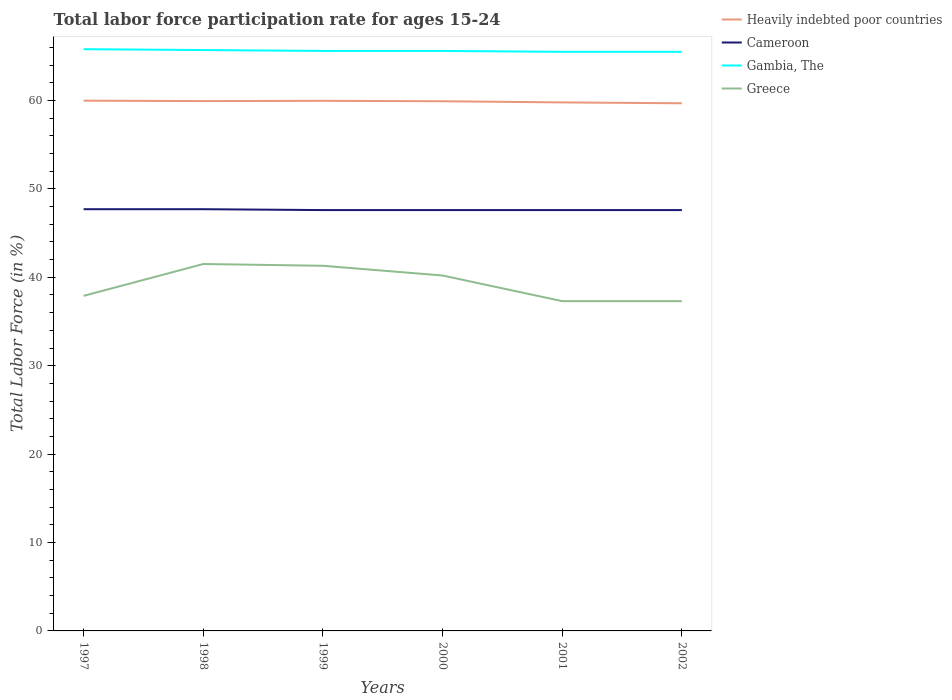Across all years, what is the maximum labor force participation rate in Cameroon?
Offer a terse response. 47.6. In which year was the labor force participation rate in Heavily indebted poor countries maximum?
Offer a very short reply. 2002. What is the total labor force participation rate in Cameroon in the graph?
Provide a succinct answer. 0. What is the difference between the highest and the second highest labor force participation rate in Cameroon?
Offer a very short reply. 0.1. What is the difference between the highest and the lowest labor force participation rate in Heavily indebted poor countries?
Your answer should be very brief. 4. Is the labor force participation rate in Heavily indebted poor countries strictly greater than the labor force participation rate in Greece over the years?
Ensure brevity in your answer.  No. How many lines are there?
Keep it short and to the point. 4. How many years are there in the graph?
Your answer should be compact. 6. What is the difference between two consecutive major ticks on the Y-axis?
Keep it short and to the point. 10. Does the graph contain any zero values?
Provide a short and direct response. No. Where does the legend appear in the graph?
Make the answer very short. Top right. How many legend labels are there?
Keep it short and to the point. 4. How are the legend labels stacked?
Offer a terse response. Vertical. What is the title of the graph?
Your response must be concise. Total labor force participation rate for ages 15-24. Does "Micronesia" appear as one of the legend labels in the graph?
Provide a short and direct response. No. What is the label or title of the X-axis?
Offer a terse response. Years. What is the Total Labor Force (in %) in Heavily indebted poor countries in 1997?
Your answer should be compact. 59.98. What is the Total Labor Force (in %) in Cameroon in 1997?
Your answer should be very brief. 47.7. What is the Total Labor Force (in %) of Gambia, The in 1997?
Give a very brief answer. 65.8. What is the Total Labor Force (in %) in Greece in 1997?
Your response must be concise. 37.9. What is the Total Labor Force (in %) of Heavily indebted poor countries in 1998?
Provide a succinct answer. 59.93. What is the Total Labor Force (in %) in Cameroon in 1998?
Offer a terse response. 47.7. What is the Total Labor Force (in %) in Gambia, The in 1998?
Ensure brevity in your answer.  65.7. What is the Total Labor Force (in %) in Greece in 1998?
Offer a very short reply. 41.5. What is the Total Labor Force (in %) in Heavily indebted poor countries in 1999?
Make the answer very short. 59.96. What is the Total Labor Force (in %) of Cameroon in 1999?
Make the answer very short. 47.6. What is the Total Labor Force (in %) of Gambia, The in 1999?
Provide a succinct answer. 65.6. What is the Total Labor Force (in %) of Greece in 1999?
Make the answer very short. 41.3. What is the Total Labor Force (in %) in Heavily indebted poor countries in 2000?
Provide a short and direct response. 59.91. What is the Total Labor Force (in %) of Cameroon in 2000?
Offer a very short reply. 47.6. What is the Total Labor Force (in %) in Gambia, The in 2000?
Your answer should be very brief. 65.6. What is the Total Labor Force (in %) in Greece in 2000?
Offer a very short reply. 40.2. What is the Total Labor Force (in %) of Heavily indebted poor countries in 2001?
Your answer should be very brief. 59.78. What is the Total Labor Force (in %) of Cameroon in 2001?
Your answer should be very brief. 47.6. What is the Total Labor Force (in %) in Gambia, The in 2001?
Your answer should be compact. 65.5. What is the Total Labor Force (in %) in Greece in 2001?
Give a very brief answer. 37.3. What is the Total Labor Force (in %) of Heavily indebted poor countries in 2002?
Make the answer very short. 59.68. What is the Total Labor Force (in %) of Cameroon in 2002?
Provide a succinct answer. 47.6. What is the Total Labor Force (in %) in Gambia, The in 2002?
Provide a short and direct response. 65.5. What is the Total Labor Force (in %) of Greece in 2002?
Make the answer very short. 37.3. Across all years, what is the maximum Total Labor Force (in %) in Heavily indebted poor countries?
Provide a succinct answer. 59.98. Across all years, what is the maximum Total Labor Force (in %) of Cameroon?
Offer a very short reply. 47.7. Across all years, what is the maximum Total Labor Force (in %) of Gambia, The?
Provide a short and direct response. 65.8. Across all years, what is the maximum Total Labor Force (in %) of Greece?
Offer a terse response. 41.5. Across all years, what is the minimum Total Labor Force (in %) of Heavily indebted poor countries?
Offer a very short reply. 59.68. Across all years, what is the minimum Total Labor Force (in %) in Cameroon?
Your answer should be compact. 47.6. Across all years, what is the minimum Total Labor Force (in %) in Gambia, The?
Give a very brief answer. 65.5. Across all years, what is the minimum Total Labor Force (in %) in Greece?
Offer a terse response. 37.3. What is the total Total Labor Force (in %) in Heavily indebted poor countries in the graph?
Your response must be concise. 359.23. What is the total Total Labor Force (in %) of Cameroon in the graph?
Give a very brief answer. 285.8. What is the total Total Labor Force (in %) of Gambia, The in the graph?
Offer a very short reply. 393.7. What is the total Total Labor Force (in %) of Greece in the graph?
Keep it short and to the point. 235.5. What is the difference between the Total Labor Force (in %) of Heavily indebted poor countries in 1997 and that in 1998?
Your answer should be compact. 0.05. What is the difference between the Total Labor Force (in %) of Cameroon in 1997 and that in 1998?
Offer a terse response. 0. What is the difference between the Total Labor Force (in %) in Heavily indebted poor countries in 1997 and that in 1999?
Your answer should be compact. 0.02. What is the difference between the Total Labor Force (in %) of Cameroon in 1997 and that in 1999?
Make the answer very short. 0.1. What is the difference between the Total Labor Force (in %) of Gambia, The in 1997 and that in 1999?
Your answer should be compact. 0.2. What is the difference between the Total Labor Force (in %) of Heavily indebted poor countries in 1997 and that in 2000?
Offer a very short reply. 0.07. What is the difference between the Total Labor Force (in %) in Cameroon in 1997 and that in 2000?
Your response must be concise. 0.1. What is the difference between the Total Labor Force (in %) in Gambia, The in 1997 and that in 2000?
Provide a short and direct response. 0.2. What is the difference between the Total Labor Force (in %) of Heavily indebted poor countries in 1997 and that in 2001?
Give a very brief answer. 0.2. What is the difference between the Total Labor Force (in %) of Cameroon in 1997 and that in 2001?
Offer a very short reply. 0.1. What is the difference between the Total Labor Force (in %) of Gambia, The in 1997 and that in 2001?
Offer a very short reply. 0.3. What is the difference between the Total Labor Force (in %) in Heavily indebted poor countries in 1997 and that in 2002?
Keep it short and to the point. 0.3. What is the difference between the Total Labor Force (in %) in Cameroon in 1997 and that in 2002?
Ensure brevity in your answer.  0.1. What is the difference between the Total Labor Force (in %) in Heavily indebted poor countries in 1998 and that in 1999?
Keep it short and to the point. -0.03. What is the difference between the Total Labor Force (in %) in Cameroon in 1998 and that in 1999?
Your response must be concise. 0.1. What is the difference between the Total Labor Force (in %) of Heavily indebted poor countries in 1998 and that in 2000?
Your response must be concise. 0.02. What is the difference between the Total Labor Force (in %) in Greece in 1998 and that in 2000?
Give a very brief answer. 1.3. What is the difference between the Total Labor Force (in %) in Heavily indebted poor countries in 1998 and that in 2001?
Your answer should be very brief. 0.15. What is the difference between the Total Labor Force (in %) of Cameroon in 1998 and that in 2001?
Offer a very short reply. 0.1. What is the difference between the Total Labor Force (in %) in Gambia, The in 1998 and that in 2001?
Your answer should be very brief. 0.2. What is the difference between the Total Labor Force (in %) of Greece in 1998 and that in 2001?
Offer a very short reply. 4.2. What is the difference between the Total Labor Force (in %) of Heavily indebted poor countries in 1998 and that in 2002?
Your answer should be compact. 0.25. What is the difference between the Total Labor Force (in %) of Gambia, The in 1998 and that in 2002?
Provide a short and direct response. 0.2. What is the difference between the Total Labor Force (in %) of Heavily indebted poor countries in 1999 and that in 2000?
Provide a short and direct response. 0.05. What is the difference between the Total Labor Force (in %) of Heavily indebted poor countries in 1999 and that in 2001?
Your response must be concise. 0.18. What is the difference between the Total Labor Force (in %) in Gambia, The in 1999 and that in 2001?
Offer a terse response. 0.1. What is the difference between the Total Labor Force (in %) in Greece in 1999 and that in 2001?
Your answer should be very brief. 4. What is the difference between the Total Labor Force (in %) in Heavily indebted poor countries in 1999 and that in 2002?
Give a very brief answer. 0.28. What is the difference between the Total Labor Force (in %) in Cameroon in 1999 and that in 2002?
Keep it short and to the point. 0. What is the difference between the Total Labor Force (in %) of Greece in 1999 and that in 2002?
Offer a very short reply. 4. What is the difference between the Total Labor Force (in %) in Heavily indebted poor countries in 2000 and that in 2001?
Your response must be concise. 0.13. What is the difference between the Total Labor Force (in %) of Cameroon in 2000 and that in 2001?
Your response must be concise. 0. What is the difference between the Total Labor Force (in %) in Gambia, The in 2000 and that in 2001?
Keep it short and to the point. 0.1. What is the difference between the Total Labor Force (in %) in Greece in 2000 and that in 2001?
Ensure brevity in your answer.  2.9. What is the difference between the Total Labor Force (in %) in Heavily indebted poor countries in 2000 and that in 2002?
Offer a terse response. 0.23. What is the difference between the Total Labor Force (in %) of Greece in 2000 and that in 2002?
Your answer should be compact. 2.9. What is the difference between the Total Labor Force (in %) of Heavily indebted poor countries in 2001 and that in 2002?
Make the answer very short. 0.1. What is the difference between the Total Labor Force (in %) of Gambia, The in 2001 and that in 2002?
Ensure brevity in your answer.  0. What is the difference between the Total Labor Force (in %) of Greece in 2001 and that in 2002?
Your answer should be very brief. 0. What is the difference between the Total Labor Force (in %) in Heavily indebted poor countries in 1997 and the Total Labor Force (in %) in Cameroon in 1998?
Your answer should be compact. 12.28. What is the difference between the Total Labor Force (in %) in Heavily indebted poor countries in 1997 and the Total Labor Force (in %) in Gambia, The in 1998?
Keep it short and to the point. -5.72. What is the difference between the Total Labor Force (in %) in Heavily indebted poor countries in 1997 and the Total Labor Force (in %) in Greece in 1998?
Your answer should be compact. 18.48. What is the difference between the Total Labor Force (in %) in Cameroon in 1997 and the Total Labor Force (in %) in Gambia, The in 1998?
Keep it short and to the point. -18. What is the difference between the Total Labor Force (in %) of Cameroon in 1997 and the Total Labor Force (in %) of Greece in 1998?
Your response must be concise. 6.2. What is the difference between the Total Labor Force (in %) in Gambia, The in 1997 and the Total Labor Force (in %) in Greece in 1998?
Offer a terse response. 24.3. What is the difference between the Total Labor Force (in %) in Heavily indebted poor countries in 1997 and the Total Labor Force (in %) in Cameroon in 1999?
Ensure brevity in your answer.  12.38. What is the difference between the Total Labor Force (in %) of Heavily indebted poor countries in 1997 and the Total Labor Force (in %) of Gambia, The in 1999?
Your response must be concise. -5.62. What is the difference between the Total Labor Force (in %) of Heavily indebted poor countries in 1997 and the Total Labor Force (in %) of Greece in 1999?
Your response must be concise. 18.68. What is the difference between the Total Labor Force (in %) in Cameroon in 1997 and the Total Labor Force (in %) in Gambia, The in 1999?
Your answer should be compact. -17.9. What is the difference between the Total Labor Force (in %) in Cameroon in 1997 and the Total Labor Force (in %) in Greece in 1999?
Your answer should be compact. 6.4. What is the difference between the Total Labor Force (in %) in Gambia, The in 1997 and the Total Labor Force (in %) in Greece in 1999?
Your answer should be compact. 24.5. What is the difference between the Total Labor Force (in %) in Heavily indebted poor countries in 1997 and the Total Labor Force (in %) in Cameroon in 2000?
Make the answer very short. 12.38. What is the difference between the Total Labor Force (in %) of Heavily indebted poor countries in 1997 and the Total Labor Force (in %) of Gambia, The in 2000?
Keep it short and to the point. -5.62. What is the difference between the Total Labor Force (in %) in Heavily indebted poor countries in 1997 and the Total Labor Force (in %) in Greece in 2000?
Your response must be concise. 19.78. What is the difference between the Total Labor Force (in %) of Cameroon in 1997 and the Total Labor Force (in %) of Gambia, The in 2000?
Your response must be concise. -17.9. What is the difference between the Total Labor Force (in %) in Cameroon in 1997 and the Total Labor Force (in %) in Greece in 2000?
Your response must be concise. 7.5. What is the difference between the Total Labor Force (in %) in Gambia, The in 1997 and the Total Labor Force (in %) in Greece in 2000?
Your response must be concise. 25.6. What is the difference between the Total Labor Force (in %) of Heavily indebted poor countries in 1997 and the Total Labor Force (in %) of Cameroon in 2001?
Your response must be concise. 12.38. What is the difference between the Total Labor Force (in %) of Heavily indebted poor countries in 1997 and the Total Labor Force (in %) of Gambia, The in 2001?
Offer a very short reply. -5.52. What is the difference between the Total Labor Force (in %) in Heavily indebted poor countries in 1997 and the Total Labor Force (in %) in Greece in 2001?
Offer a very short reply. 22.68. What is the difference between the Total Labor Force (in %) in Cameroon in 1997 and the Total Labor Force (in %) in Gambia, The in 2001?
Offer a very short reply. -17.8. What is the difference between the Total Labor Force (in %) of Cameroon in 1997 and the Total Labor Force (in %) of Greece in 2001?
Provide a short and direct response. 10.4. What is the difference between the Total Labor Force (in %) in Gambia, The in 1997 and the Total Labor Force (in %) in Greece in 2001?
Your response must be concise. 28.5. What is the difference between the Total Labor Force (in %) of Heavily indebted poor countries in 1997 and the Total Labor Force (in %) of Cameroon in 2002?
Offer a terse response. 12.38. What is the difference between the Total Labor Force (in %) in Heavily indebted poor countries in 1997 and the Total Labor Force (in %) in Gambia, The in 2002?
Your answer should be very brief. -5.52. What is the difference between the Total Labor Force (in %) in Heavily indebted poor countries in 1997 and the Total Labor Force (in %) in Greece in 2002?
Make the answer very short. 22.68. What is the difference between the Total Labor Force (in %) of Cameroon in 1997 and the Total Labor Force (in %) of Gambia, The in 2002?
Offer a very short reply. -17.8. What is the difference between the Total Labor Force (in %) of Cameroon in 1997 and the Total Labor Force (in %) of Greece in 2002?
Your response must be concise. 10.4. What is the difference between the Total Labor Force (in %) of Gambia, The in 1997 and the Total Labor Force (in %) of Greece in 2002?
Your answer should be very brief. 28.5. What is the difference between the Total Labor Force (in %) in Heavily indebted poor countries in 1998 and the Total Labor Force (in %) in Cameroon in 1999?
Make the answer very short. 12.33. What is the difference between the Total Labor Force (in %) of Heavily indebted poor countries in 1998 and the Total Labor Force (in %) of Gambia, The in 1999?
Your response must be concise. -5.67. What is the difference between the Total Labor Force (in %) of Heavily indebted poor countries in 1998 and the Total Labor Force (in %) of Greece in 1999?
Offer a very short reply. 18.63. What is the difference between the Total Labor Force (in %) in Cameroon in 1998 and the Total Labor Force (in %) in Gambia, The in 1999?
Make the answer very short. -17.9. What is the difference between the Total Labor Force (in %) in Gambia, The in 1998 and the Total Labor Force (in %) in Greece in 1999?
Offer a very short reply. 24.4. What is the difference between the Total Labor Force (in %) in Heavily indebted poor countries in 1998 and the Total Labor Force (in %) in Cameroon in 2000?
Make the answer very short. 12.33. What is the difference between the Total Labor Force (in %) in Heavily indebted poor countries in 1998 and the Total Labor Force (in %) in Gambia, The in 2000?
Provide a short and direct response. -5.67. What is the difference between the Total Labor Force (in %) in Heavily indebted poor countries in 1998 and the Total Labor Force (in %) in Greece in 2000?
Your answer should be very brief. 19.73. What is the difference between the Total Labor Force (in %) of Cameroon in 1998 and the Total Labor Force (in %) of Gambia, The in 2000?
Provide a succinct answer. -17.9. What is the difference between the Total Labor Force (in %) of Heavily indebted poor countries in 1998 and the Total Labor Force (in %) of Cameroon in 2001?
Your answer should be very brief. 12.33. What is the difference between the Total Labor Force (in %) of Heavily indebted poor countries in 1998 and the Total Labor Force (in %) of Gambia, The in 2001?
Offer a terse response. -5.57. What is the difference between the Total Labor Force (in %) of Heavily indebted poor countries in 1998 and the Total Labor Force (in %) of Greece in 2001?
Offer a very short reply. 22.63. What is the difference between the Total Labor Force (in %) in Cameroon in 1998 and the Total Labor Force (in %) in Gambia, The in 2001?
Ensure brevity in your answer.  -17.8. What is the difference between the Total Labor Force (in %) of Cameroon in 1998 and the Total Labor Force (in %) of Greece in 2001?
Ensure brevity in your answer.  10.4. What is the difference between the Total Labor Force (in %) in Gambia, The in 1998 and the Total Labor Force (in %) in Greece in 2001?
Offer a very short reply. 28.4. What is the difference between the Total Labor Force (in %) in Heavily indebted poor countries in 1998 and the Total Labor Force (in %) in Cameroon in 2002?
Keep it short and to the point. 12.33. What is the difference between the Total Labor Force (in %) in Heavily indebted poor countries in 1998 and the Total Labor Force (in %) in Gambia, The in 2002?
Offer a terse response. -5.57. What is the difference between the Total Labor Force (in %) in Heavily indebted poor countries in 1998 and the Total Labor Force (in %) in Greece in 2002?
Your response must be concise. 22.63. What is the difference between the Total Labor Force (in %) of Cameroon in 1998 and the Total Labor Force (in %) of Gambia, The in 2002?
Your answer should be very brief. -17.8. What is the difference between the Total Labor Force (in %) of Cameroon in 1998 and the Total Labor Force (in %) of Greece in 2002?
Ensure brevity in your answer.  10.4. What is the difference between the Total Labor Force (in %) in Gambia, The in 1998 and the Total Labor Force (in %) in Greece in 2002?
Your response must be concise. 28.4. What is the difference between the Total Labor Force (in %) of Heavily indebted poor countries in 1999 and the Total Labor Force (in %) of Cameroon in 2000?
Keep it short and to the point. 12.36. What is the difference between the Total Labor Force (in %) in Heavily indebted poor countries in 1999 and the Total Labor Force (in %) in Gambia, The in 2000?
Offer a very short reply. -5.64. What is the difference between the Total Labor Force (in %) of Heavily indebted poor countries in 1999 and the Total Labor Force (in %) of Greece in 2000?
Your answer should be compact. 19.76. What is the difference between the Total Labor Force (in %) of Cameroon in 1999 and the Total Labor Force (in %) of Gambia, The in 2000?
Your answer should be compact. -18. What is the difference between the Total Labor Force (in %) in Gambia, The in 1999 and the Total Labor Force (in %) in Greece in 2000?
Ensure brevity in your answer.  25.4. What is the difference between the Total Labor Force (in %) in Heavily indebted poor countries in 1999 and the Total Labor Force (in %) in Cameroon in 2001?
Your response must be concise. 12.36. What is the difference between the Total Labor Force (in %) of Heavily indebted poor countries in 1999 and the Total Labor Force (in %) of Gambia, The in 2001?
Keep it short and to the point. -5.54. What is the difference between the Total Labor Force (in %) in Heavily indebted poor countries in 1999 and the Total Labor Force (in %) in Greece in 2001?
Provide a succinct answer. 22.66. What is the difference between the Total Labor Force (in %) in Cameroon in 1999 and the Total Labor Force (in %) in Gambia, The in 2001?
Keep it short and to the point. -17.9. What is the difference between the Total Labor Force (in %) of Cameroon in 1999 and the Total Labor Force (in %) of Greece in 2001?
Give a very brief answer. 10.3. What is the difference between the Total Labor Force (in %) of Gambia, The in 1999 and the Total Labor Force (in %) of Greece in 2001?
Offer a terse response. 28.3. What is the difference between the Total Labor Force (in %) in Heavily indebted poor countries in 1999 and the Total Labor Force (in %) in Cameroon in 2002?
Provide a short and direct response. 12.36. What is the difference between the Total Labor Force (in %) in Heavily indebted poor countries in 1999 and the Total Labor Force (in %) in Gambia, The in 2002?
Make the answer very short. -5.54. What is the difference between the Total Labor Force (in %) of Heavily indebted poor countries in 1999 and the Total Labor Force (in %) of Greece in 2002?
Your answer should be very brief. 22.66. What is the difference between the Total Labor Force (in %) of Cameroon in 1999 and the Total Labor Force (in %) of Gambia, The in 2002?
Provide a short and direct response. -17.9. What is the difference between the Total Labor Force (in %) in Cameroon in 1999 and the Total Labor Force (in %) in Greece in 2002?
Provide a succinct answer. 10.3. What is the difference between the Total Labor Force (in %) of Gambia, The in 1999 and the Total Labor Force (in %) of Greece in 2002?
Your answer should be very brief. 28.3. What is the difference between the Total Labor Force (in %) in Heavily indebted poor countries in 2000 and the Total Labor Force (in %) in Cameroon in 2001?
Your answer should be compact. 12.31. What is the difference between the Total Labor Force (in %) in Heavily indebted poor countries in 2000 and the Total Labor Force (in %) in Gambia, The in 2001?
Your answer should be compact. -5.59. What is the difference between the Total Labor Force (in %) in Heavily indebted poor countries in 2000 and the Total Labor Force (in %) in Greece in 2001?
Provide a short and direct response. 22.61. What is the difference between the Total Labor Force (in %) in Cameroon in 2000 and the Total Labor Force (in %) in Gambia, The in 2001?
Keep it short and to the point. -17.9. What is the difference between the Total Labor Force (in %) of Gambia, The in 2000 and the Total Labor Force (in %) of Greece in 2001?
Give a very brief answer. 28.3. What is the difference between the Total Labor Force (in %) in Heavily indebted poor countries in 2000 and the Total Labor Force (in %) in Cameroon in 2002?
Make the answer very short. 12.31. What is the difference between the Total Labor Force (in %) of Heavily indebted poor countries in 2000 and the Total Labor Force (in %) of Gambia, The in 2002?
Provide a succinct answer. -5.59. What is the difference between the Total Labor Force (in %) of Heavily indebted poor countries in 2000 and the Total Labor Force (in %) of Greece in 2002?
Your answer should be compact. 22.61. What is the difference between the Total Labor Force (in %) of Cameroon in 2000 and the Total Labor Force (in %) of Gambia, The in 2002?
Your response must be concise. -17.9. What is the difference between the Total Labor Force (in %) in Cameroon in 2000 and the Total Labor Force (in %) in Greece in 2002?
Keep it short and to the point. 10.3. What is the difference between the Total Labor Force (in %) of Gambia, The in 2000 and the Total Labor Force (in %) of Greece in 2002?
Your answer should be very brief. 28.3. What is the difference between the Total Labor Force (in %) of Heavily indebted poor countries in 2001 and the Total Labor Force (in %) of Cameroon in 2002?
Your response must be concise. 12.18. What is the difference between the Total Labor Force (in %) in Heavily indebted poor countries in 2001 and the Total Labor Force (in %) in Gambia, The in 2002?
Provide a succinct answer. -5.72. What is the difference between the Total Labor Force (in %) in Heavily indebted poor countries in 2001 and the Total Labor Force (in %) in Greece in 2002?
Offer a terse response. 22.48. What is the difference between the Total Labor Force (in %) of Cameroon in 2001 and the Total Labor Force (in %) of Gambia, The in 2002?
Give a very brief answer. -17.9. What is the difference between the Total Labor Force (in %) of Cameroon in 2001 and the Total Labor Force (in %) of Greece in 2002?
Keep it short and to the point. 10.3. What is the difference between the Total Labor Force (in %) in Gambia, The in 2001 and the Total Labor Force (in %) in Greece in 2002?
Offer a terse response. 28.2. What is the average Total Labor Force (in %) in Heavily indebted poor countries per year?
Offer a terse response. 59.87. What is the average Total Labor Force (in %) in Cameroon per year?
Give a very brief answer. 47.63. What is the average Total Labor Force (in %) of Gambia, The per year?
Your answer should be very brief. 65.62. What is the average Total Labor Force (in %) of Greece per year?
Provide a succinct answer. 39.25. In the year 1997, what is the difference between the Total Labor Force (in %) of Heavily indebted poor countries and Total Labor Force (in %) of Cameroon?
Keep it short and to the point. 12.28. In the year 1997, what is the difference between the Total Labor Force (in %) in Heavily indebted poor countries and Total Labor Force (in %) in Gambia, The?
Your answer should be very brief. -5.82. In the year 1997, what is the difference between the Total Labor Force (in %) of Heavily indebted poor countries and Total Labor Force (in %) of Greece?
Make the answer very short. 22.08. In the year 1997, what is the difference between the Total Labor Force (in %) of Cameroon and Total Labor Force (in %) of Gambia, The?
Make the answer very short. -18.1. In the year 1997, what is the difference between the Total Labor Force (in %) of Cameroon and Total Labor Force (in %) of Greece?
Your answer should be very brief. 9.8. In the year 1997, what is the difference between the Total Labor Force (in %) of Gambia, The and Total Labor Force (in %) of Greece?
Your answer should be very brief. 27.9. In the year 1998, what is the difference between the Total Labor Force (in %) in Heavily indebted poor countries and Total Labor Force (in %) in Cameroon?
Offer a terse response. 12.23. In the year 1998, what is the difference between the Total Labor Force (in %) of Heavily indebted poor countries and Total Labor Force (in %) of Gambia, The?
Provide a short and direct response. -5.77. In the year 1998, what is the difference between the Total Labor Force (in %) in Heavily indebted poor countries and Total Labor Force (in %) in Greece?
Your answer should be very brief. 18.43. In the year 1998, what is the difference between the Total Labor Force (in %) of Gambia, The and Total Labor Force (in %) of Greece?
Provide a short and direct response. 24.2. In the year 1999, what is the difference between the Total Labor Force (in %) in Heavily indebted poor countries and Total Labor Force (in %) in Cameroon?
Ensure brevity in your answer.  12.36. In the year 1999, what is the difference between the Total Labor Force (in %) in Heavily indebted poor countries and Total Labor Force (in %) in Gambia, The?
Give a very brief answer. -5.64. In the year 1999, what is the difference between the Total Labor Force (in %) in Heavily indebted poor countries and Total Labor Force (in %) in Greece?
Offer a very short reply. 18.66. In the year 1999, what is the difference between the Total Labor Force (in %) in Cameroon and Total Labor Force (in %) in Greece?
Provide a succinct answer. 6.3. In the year 1999, what is the difference between the Total Labor Force (in %) in Gambia, The and Total Labor Force (in %) in Greece?
Provide a succinct answer. 24.3. In the year 2000, what is the difference between the Total Labor Force (in %) in Heavily indebted poor countries and Total Labor Force (in %) in Cameroon?
Keep it short and to the point. 12.31. In the year 2000, what is the difference between the Total Labor Force (in %) in Heavily indebted poor countries and Total Labor Force (in %) in Gambia, The?
Ensure brevity in your answer.  -5.69. In the year 2000, what is the difference between the Total Labor Force (in %) in Heavily indebted poor countries and Total Labor Force (in %) in Greece?
Your answer should be very brief. 19.71. In the year 2000, what is the difference between the Total Labor Force (in %) of Cameroon and Total Labor Force (in %) of Gambia, The?
Provide a succinct answer. -18. In the year 2000, what is the difference between the Total Labor Force (in %) in Cameroon and Total Labor Force (in %) in Greece?
Provide a succinct answer. 7.4. In the year 2000, what is the difference between the Total Labor Force (in %) in Gambia, The and Total Labor Force (in %) in Greece?
Give a very brief answer. 25.4. In the year 2001, what is the difference between the Total Labor Force (in %) in Heavily indebted poor countries and Total Labor Force (in %) in Cameroon?
Offer a very short reply. 12.18. In the year 2001, what is the difference between the Total Labor Force (in %) in Heavily indebted poor countries and Total Labor Force (in %) in Gambia, The?
Your answer should be very brief. -5.72. In the year 2001, what is the difference between the Total Labor Force (in %) of Heavily indebted poor countries and Total Labor Force (in %) of Greece?
Provide a short and direct response. 22.48. In the year 2001, what is the difference between the Total Labor Force (in %) of Cameroon and Total Labor Force (in %) of Gambia, The?
Offer a terse response. -17.9. In the year 2001, what is the difference between the Total Labor Force (in %) of Cameroon and Total Labor Force (in %) of Greece?
Provide a short and direct response. 10.3. In the year 2001, what is the difference between the Total Labor Force (in %) in Gambia, The and Total Labor Force (in %) in Greece?
Provide a succinct answer. 28.2. In the year 2002, what is the difference between the Total Labor Force (in %) in Heavily indebted poor countries and Total Labor Force (in %) in Cameroon?
Provide a succinct answer. 12.08. In the year 2002, what is the difference between the Total Labor Force (in %) in Heavily indebted poor countries and Total Labor Force (in %) in Gambia, The?
Provide a succinct answer. -5.82. In the year 2002, what is the difference between the Total Labor Force (in %) in Heavily indebted poor countries and Total Labor Force (in %) in Greece?
Make the answer very short. 22.38. In the year 2002, what is the difference between the Total Labor Force (in %) of Cameroon and Total Labor Force (in %) of Gambia, The?
Ensure brevity in your answer.  -17.9. In the year 2002, what is the difference between the Total Labor Force (in %) in Cameroon and Total Labor Force (in %) in Greece?
Offer a very short reply. 10.3. In the year 2002, what is the difference between the Total Labor Force (in %) in Gambia, The and Total Labor Force (in %) in Greece?
Keep it short and to the point. 28.2. What is the ratio of the Total Labor Force (in %) of Cameroon in 1997 to that in 1998?
Your answer should be very brief. 1. What is the ratio of the Total Labor Force (in %) in Gambia, The in 1997 to that in 1998?
Offer a very short reply. 1. What is the ratio of the Total Labor Force (in %) in Greece in 1997 to that in 1998?
Provide a succinct answer. 0.91. What is the ratio of the Total Labor Force (in %) of Gambia, The in 1997 to that in 1999?
Provide a succinct answer. 1. What is the ratio of the Total Labor Force (in %) in Greece in 1997 to that in 1999?
Your answer should be very brief. 0.92. What is the ratio of the Total Labor Force (in %) in Cameroon in 1997 to that in 2000?
Your answer should be very brief. 1. What is the ratio of the Total Labor Force (in %) of Greece in 1997 to that in 2000?
Offer a very short reply. 0.94. What is the ratio of the Total Labor Force (in %) of Heavily indebted poor countries in 1997 to that in 2001?
Your response must be concise. 1. What is the ratio of the Total Labor Force (in %) of Greece in 1997 to that in 2001?
Provide a short and direct response. 1.02. What is the ratio of the Total Labor Force (in %) of Gambia, The in 1997 to that in 2002?
Offer a terse response. 1. What is the ratio of the Total Labor Force (in %) of Greece in 1997 to that in 2002?
Provide a succinct answer. 1.02. What is the ratio of the Total Labor Force (in %) of Heavily indebted poor countries in 1998 to that in 1999?
Give a very brief answer. 1. What is the ratio of the Total Labor Force (in %) of Cameroon in 1998 to that in 1999?
Your response must be concise. 1. What is the ratio of the Total Labor Force (in %) in Greece in 1998 to that in 1999?
Keep it short and to the point. 1. What is the ratio of the Total Labor Force (in %) in Greece in 1998 to that in 2000?
Provide a succinct answer. 1.03. What is the ratio of the Total Labor Force (in %) of Heavily indebted poor countries in 1998 to that in 2001?
Provide a short and direct response. 1. What is the ratio of the Total Labor Force (in %) of Gambia, The in 1998 to that in 2001?
Your answer should be compact. 1. What is the ratio of the Total Labor Force (in %) of Greece in 1998 to that in 2001?
Keep it short and to the point. 1.11. What is the ratio of the Total Labor Force (in %) in Greece in 1998 to that in 2002?
Ensure brevity in your answer.  1.11. What is the ratio of the Total Labor Force (in %) of Cameroon in 1999 to that in 2000?
Your response must be concise. 1. What is the ratio of the Total Labor Force (in %) of Greece in 1999 to that in 2000?
Make the answer very short. 1.03. What is the ratio of the Total Labor Force (in %) of Heavily indebted poor countries in 1999 to that in 2001?
Ensure brevity in your answer.  1. What is the ratio of the Total Labor Force (in %) in Cameroon in 1999 to that in 2001?
Give a very brief answer. 1. What is the ratio of the Total Labor Force (in %) of Gambia, The in 1999 to that in 2001?
Provide a short and direct response. 1. What is the ratio of the Total Labor Force (in %) in Greece in 1999 to that in 2001?
Offer a very short reply. 1.11. What is the ratio of the Total Labor Force (in %) of Heavily indebted poor countries in 1999 to that in 2002?
Your answer should be compact. 1. What is the ratio of the Total Labor Force (in %) in Gambia, The in 1999 to that in 2002?
Provide a succinct answer. 1. What is the ratio of the Total Labor Force (in %) in Greece in 1999 to that in 2002?
Ensure brevity in your answer.  1.11. What is the ratio of the Total Labor Force (in %) in Heavily indebted poor countries in 2000 to that in 2001?
Ensure brevity in your answer.  1. What is the ratio of the Total Labor Force (in %) in Cameroon in 2000 to that in 2001?
Ensure brevity in your answer.  1. What is the ratio of the Total Labor Force (in %) of Gambia, The in 2000 to that in 2001?
Provide a succinct answer. 1. What is the ratio of the Total Labor Force (in %) of Greece in 2000 to that in 2001?
Provide a succinct answer. 1.08. What is the ratio of the Total Labor Force (in %) in Heavily indebted poor countries in 2000 to that in 2002?
Offer a very short reply. 1. What is the ratio of the Total Labor Force (in %) in Greece in 2000 to that in 2002?
Ensure brevity in your answer.  1.08. What is the ratio of the Total Labor Force (in %) in Heavily indebted poor countries in 2001 to that in 2002?
Your answer should be very brief. 1. What is the ratio of the Total Labor Force (in %) in Cameroon in 2001 to that in 2002?
Offer a terse response. 1. What is the ratio of the Total Labor Force (in %) of Gambia, The in 2001 to that in 2002?
Your answer should be very brief. 1. What is the difference between the highest and the second highest Total Labor Force (in %) of Heavily indebted poor countries?
Provide a succinct answer. 0.02. What is the difference between the highest and the second highest Total Labor Force (in %) of Gambia, The?
Provide a succinct answer. 0.1. What is the difference between the highest and the second highest Total Labor Force (in %) of Greece?
Provide a short and direct response. 0.2. What is the difference between the highest and the lowest Total Labor Force (in %) in Heavily indebted poor countries?
Give a very brief answer. 0.3. What is the difference between the highest and the lowest Total Labor Force (in %) of Cameroon?
Provide a succinct answer. 0.1. What is the difference between the highest and the lowest Total Labor Force (in %) in Gambia, The?
Your answer should be compact. 0.3. 